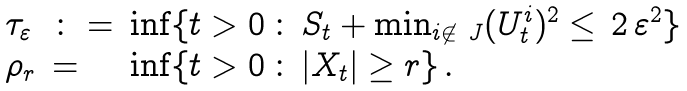Convert formula to latex. <formula><loc_0><loc_0><loc_500><loc_500>\begin{array} { l l l } \tau _ { \varepsilon } & \colon = & \inf \{ t > 0 \, \colon \, S _ { t } + \min _ { i \not \in \ J } ( U _ { t } ^ { i } ) ^ { 2 } \leq \, 2 \, \varepsilon ^ { 2 } \} \\ \rho _ { r } & = & \inf \{ t > 0 \, \colon \, | X _ { t } | \geq r \} \, . \end{array}</formula> 